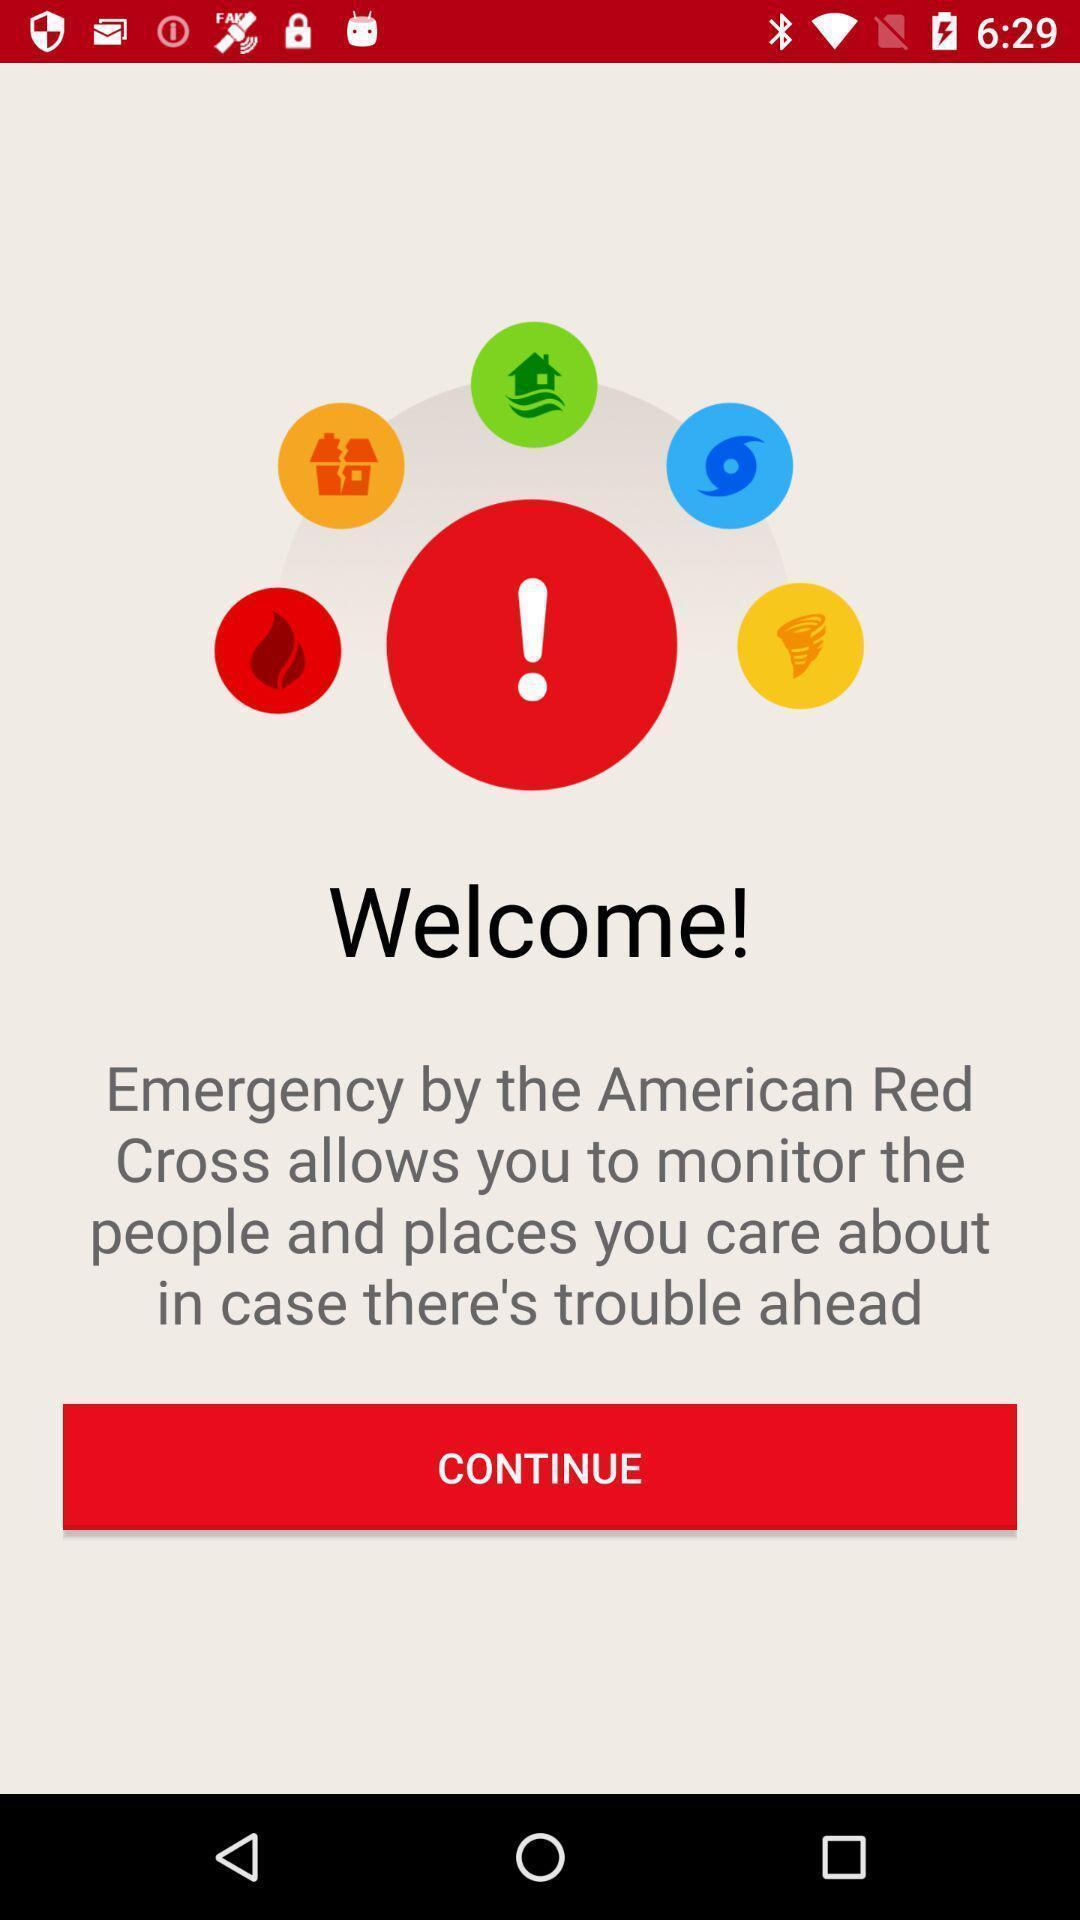Describe the key features of this screenshot. Welcome page. 